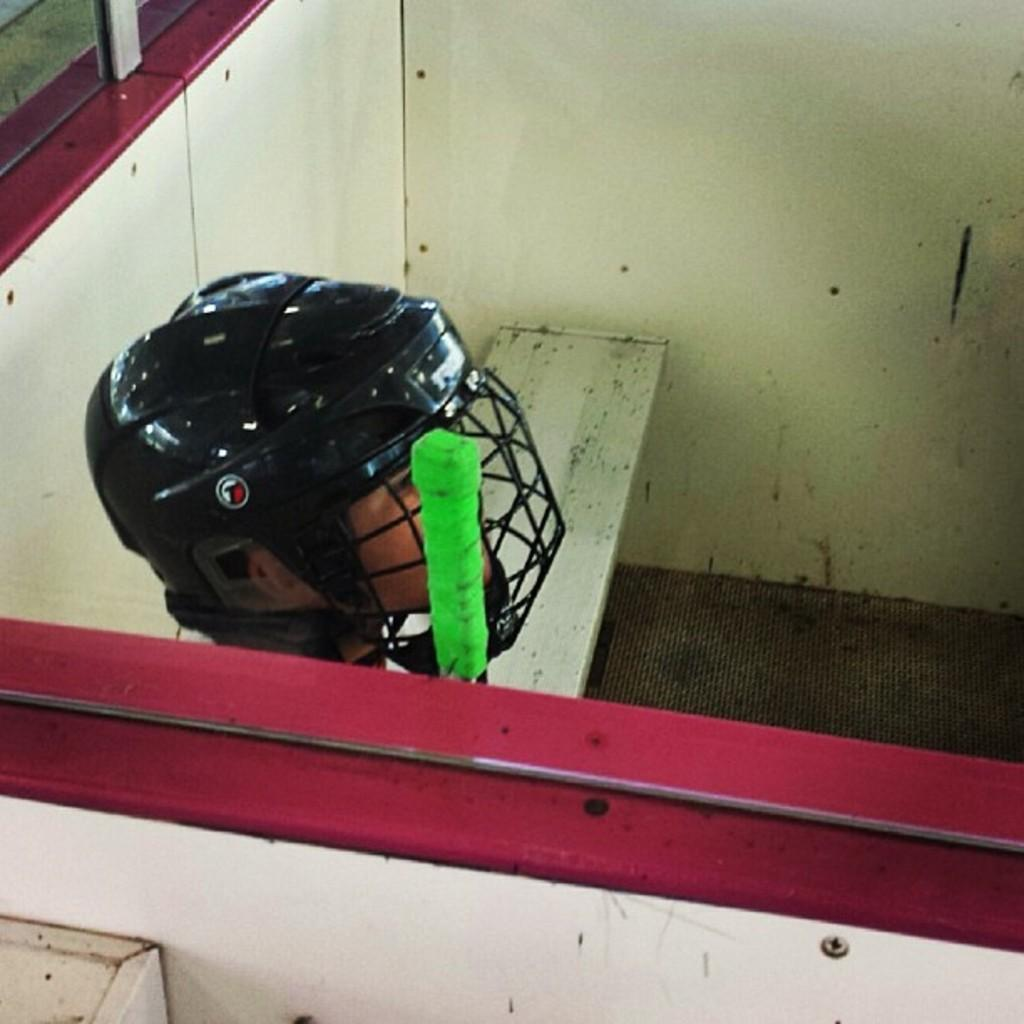What is the person in the image wearing on their head? The person in the image is wearing a helmet. What can be seen through the windows in the image? The presence of windows suggests that there is a view or scenery visible through them. What type of furniture is in the image? There is a bench in the image. What type of structure is visible in the image? There is a wall in the image. What color is the green object in the image? The green object in the image is green. What type of writing can be seen on the wall in the image? There is no writing visible on the wall in the image. 